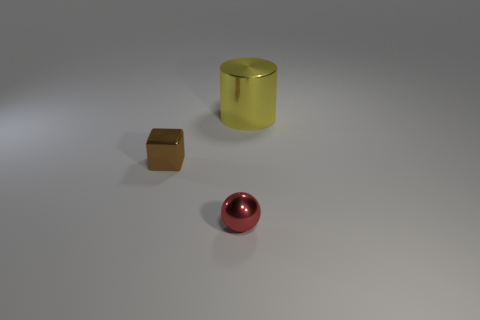Add 1 brown blocks. How many objects exist? 4 Subtract all blocks. How many objects are left? 2 Add 3 big yellow metal cylinders. How many big yellow metal cylinders exist? 4 Subtract 0 purple balls. How many objects are left? 3 Subtract all big blue rubber cylinders. Subtract all big yellow metallic objects. How many objects are left? 2 Add 2 metallic balls. How many metallic balls are left? 3 